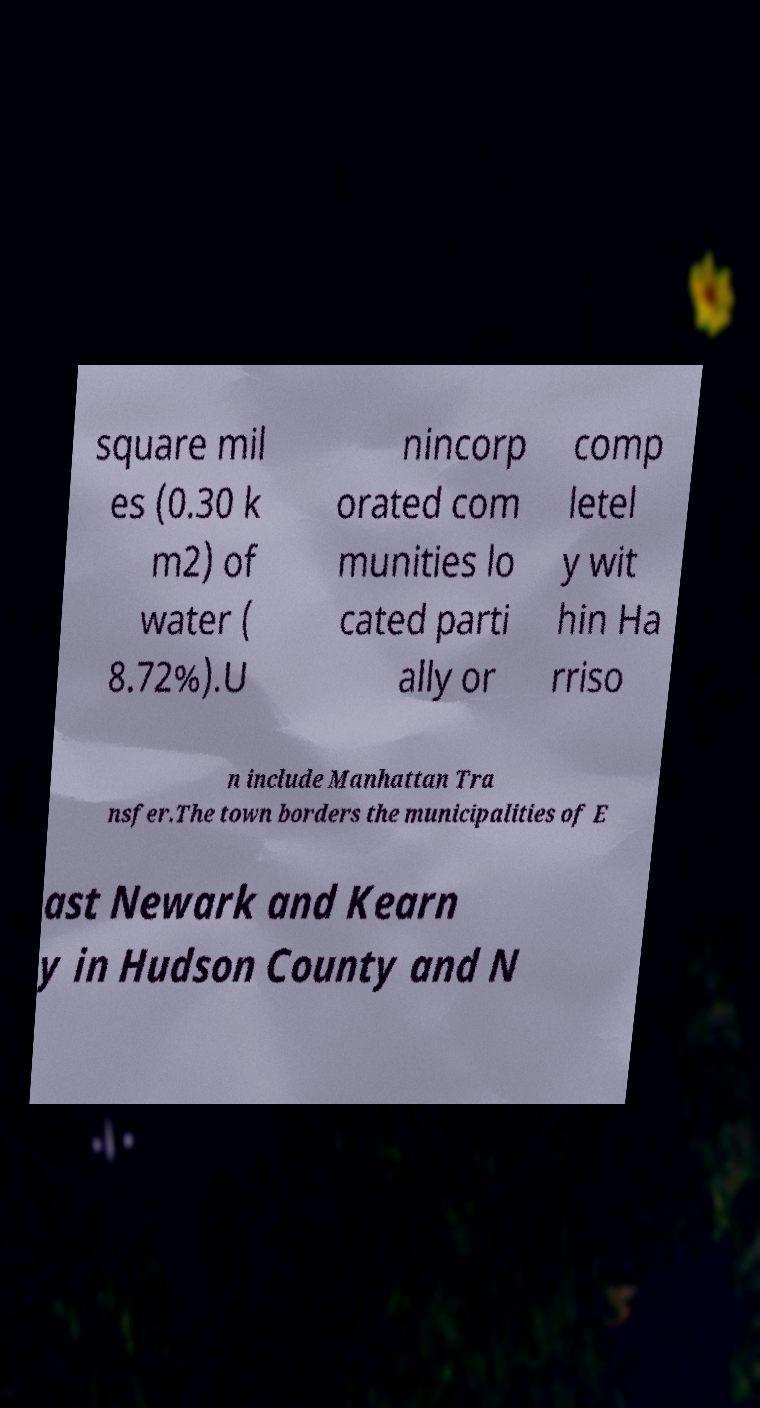Could you assist in decoding the text presented in this image and type it out clearly? square mil es (0.30 k m2) of water ( 8.72%).U nincorp orated com munities lo cated parti ally or comp letel y wit hin Ha rriso n include Manhattan Tra nsfer.The town borders the municipalities of E ast Newark and Kearn y in Hudson County and N 